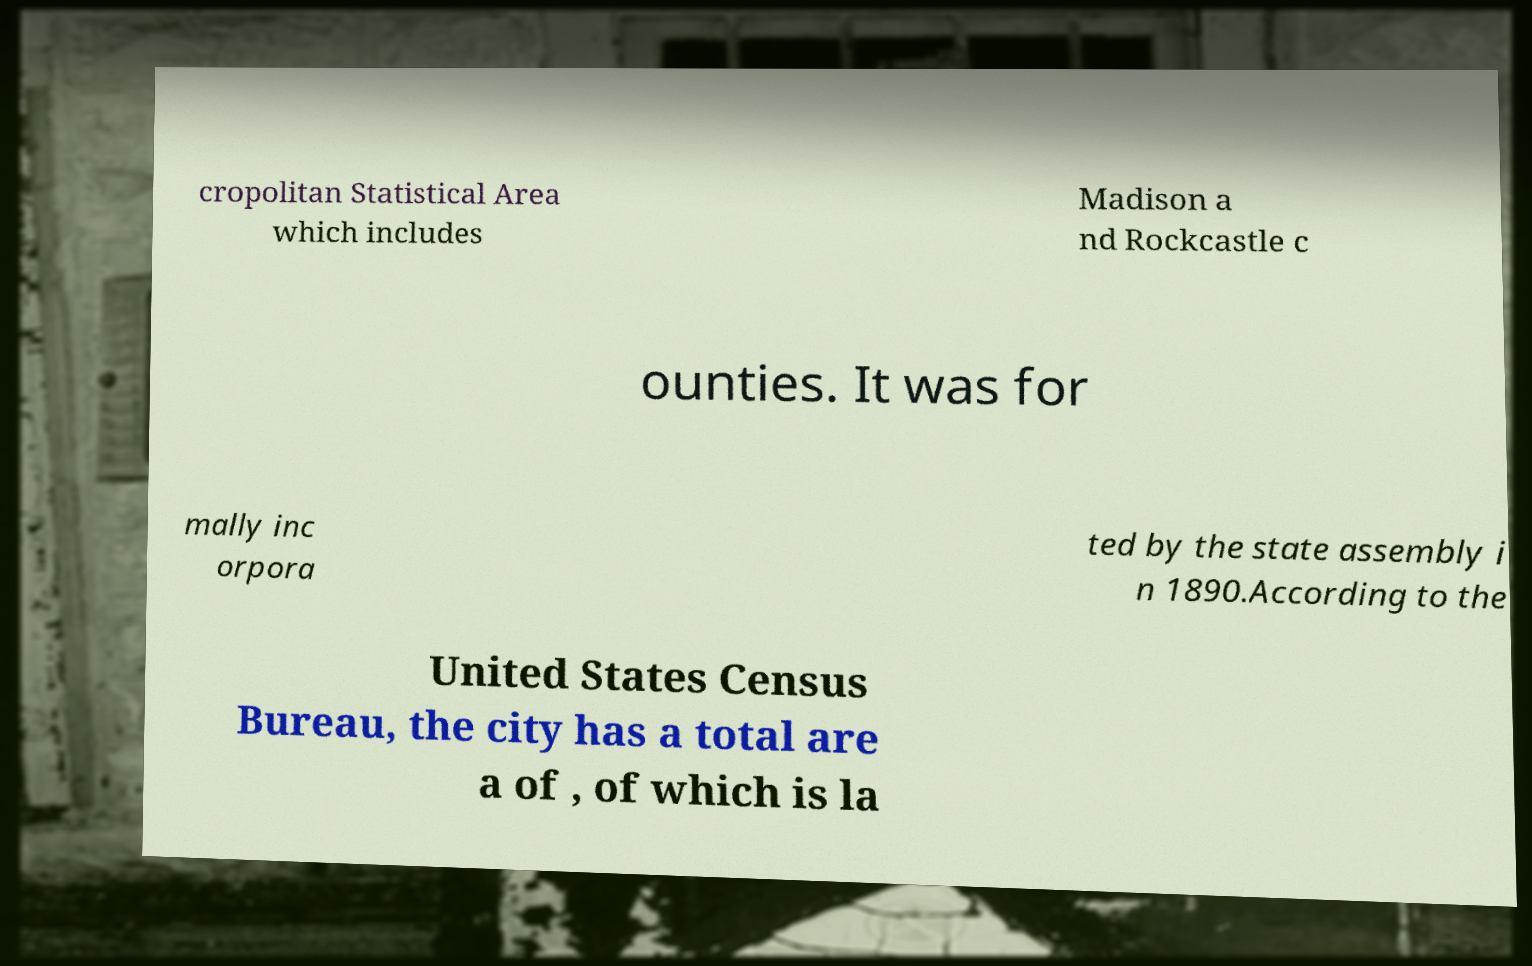Could you assist in decoding the text presented in this image and type it out clearly? cropolitan Statistical Area which includes Madison a nd Rockcastle c ounties. It was for mally inc orpora ted by the state assembly i n 1890.According to the United States Census Bureau, the city has a total are a of , of which is la 